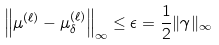<formula> <loc_0><loc_0><loc_500><loc_500>\left \| \mu ^ { ( \ell ) } - \mu _ { \delta } ^ { ( \ell ) } \right \| _ { \infty } \leq \epsilon = \frac { 1 } { 2 } \| \gamma \| _ { \infty }</formula> 